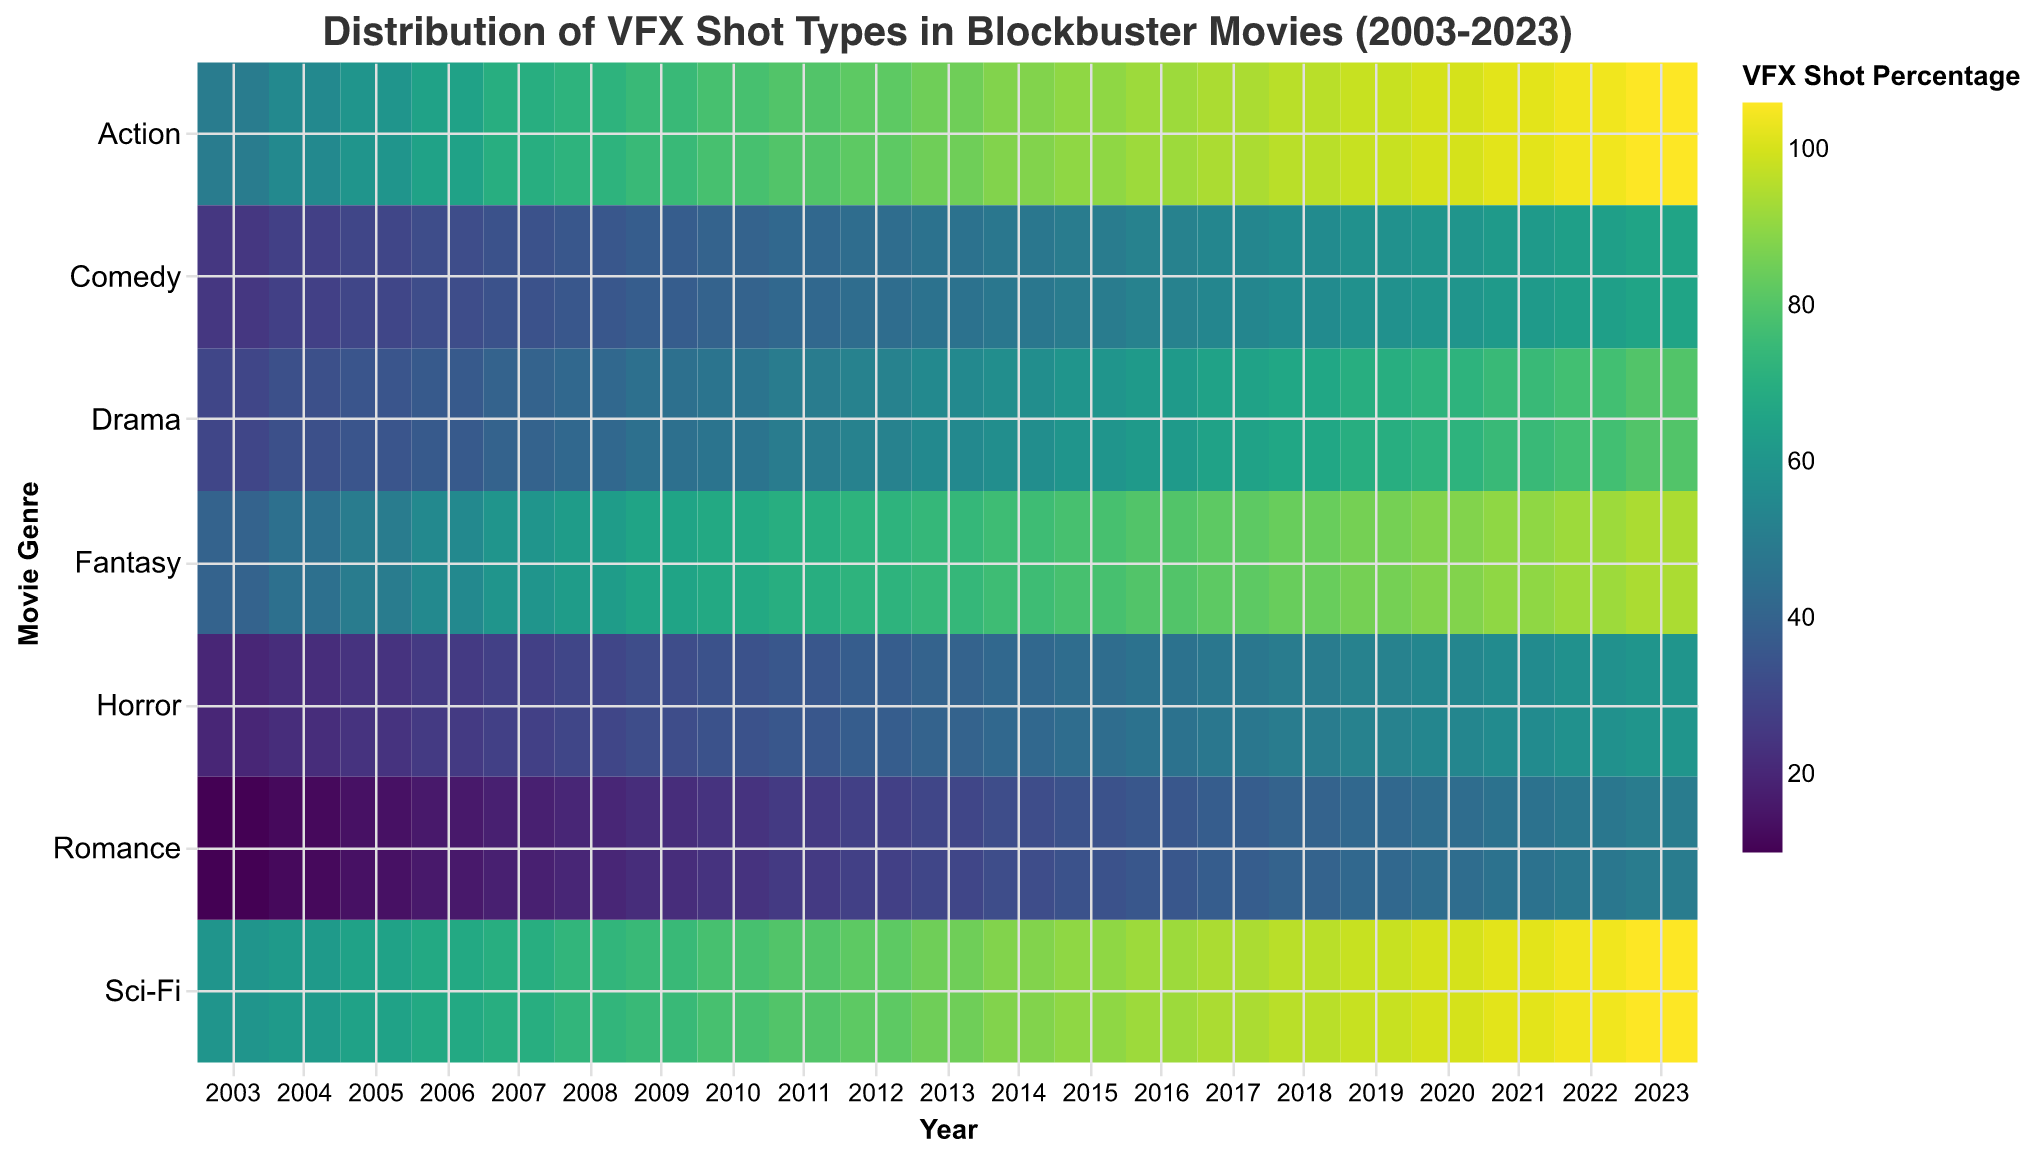How does the distribution of VFX shot percentages in Action movies change from 2003 to 2023? By observing the heatmap, locate the row corresponding to the 'Action' genre and trace left to right from 2003 to 2023. Note the increasing color intensity which signifies higher VFX shot percentages over the years.
Answer: Increasing Which genre had the highest increase in VFX shots from 2003 to 2023? Compare the color intensity for each genre from 2003 to 2023. The genre with the largest difference in color intensity signifies the highest increase. 'Action' shows the highest increase, from 50 in 2003 to 106 in 2023.
Answer: Action In which year did Sci-Fi movies have the highest VFX shot percentage? Locate the row corresponding to the 'Sci-Fi' genre, then find the year with the highest color intensity. The darkest color in the 'Sci-Fi' row corresponds to 2023, indicating the highest VFX shot percentage.
Answer: 2023 Compare the VFX shot percentages for Romance and Horror genres in 2015. Which one is higher? Find the columns for Romance and Horror in the 2015 row. Compare the color intensities or tooltip values; Romance has 34% and Horror has 44%.
Answer: Horror What is the general trend in VFX shot percentages for Comedy movies over these 20 years? Trace the 'Comedy' row from 2003 to 2023. Note the increasing color intensity, indicating a rising trend in VFX shot percentages over the years.
Answer: Increasing Determine which year Drama movies had a 50% VFX shot percentage. Look at the 'Drama' row and find the year corresponding to a 50% VFX shot percentage using tooltip values or color intensity. This is in 2011.
Answer: 2011 Which genre in 2010 had the lowest VFX shot percentage? Examine the 2010 column and compare the rows to find the genre with the lowest color intensity. 'Romance' has the lowest VFX shot percentage in 2010 with 24%.
Answer: Romance How do VFX shot percentages in Fantasy movies in 2005 compare to those in 2020? Locate the 'Fantasy' row and compare the values for the years 2005 and 2020 using tooltip values or color intensity. 2005 has 50% and 2020 has 88%.
Answer: 2020 is higher Find the year where Horror movies had a VFX shot percentage of 54%. Look at the 'Horror' row and identify the year corresponding to the 54% VFX shot percentage using tooltip values. This is in 2020.
Answer: 2020 Which genre consistently shows a steady increase in VFX shot percentages from 2003 to 2023? Trace each genre row from 2003 to 2023 and observe the color intensity for consistent gradual increases. 'Action', 'Sci-Fi', and 'Fantasy' show steady increases, with 'Action' being the most consistent.
Answer: Action 